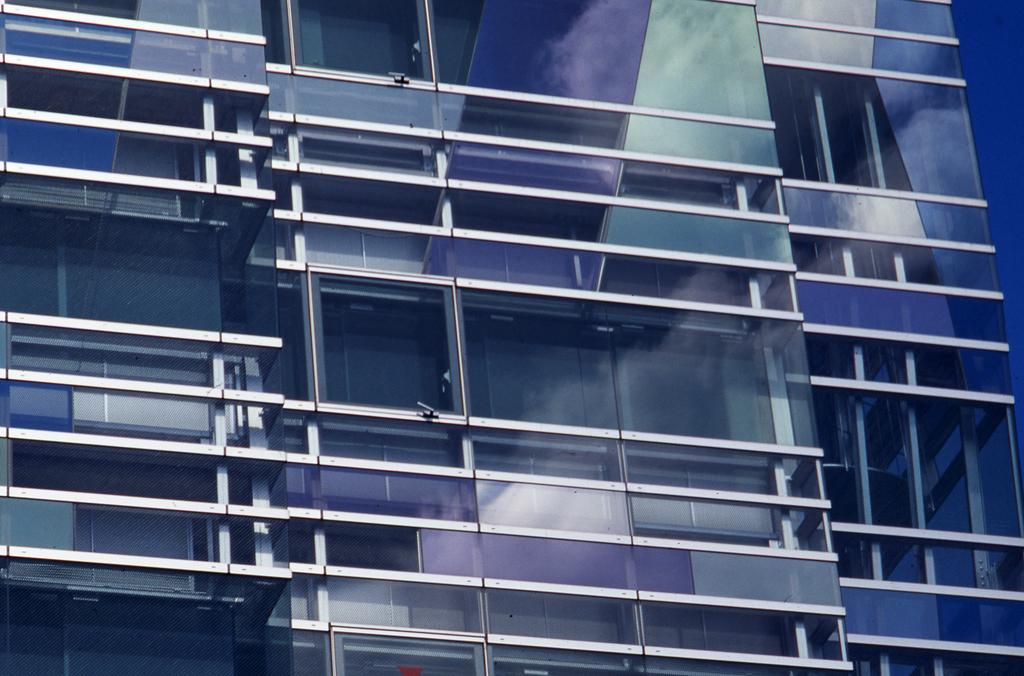What type of structure is visible in the image? There is a building in the image. What type of brush is used to answer questions about the building in the image? There is no brush or need to answer questions about the building in the image; the question can be answered directly based on the provided fact. 